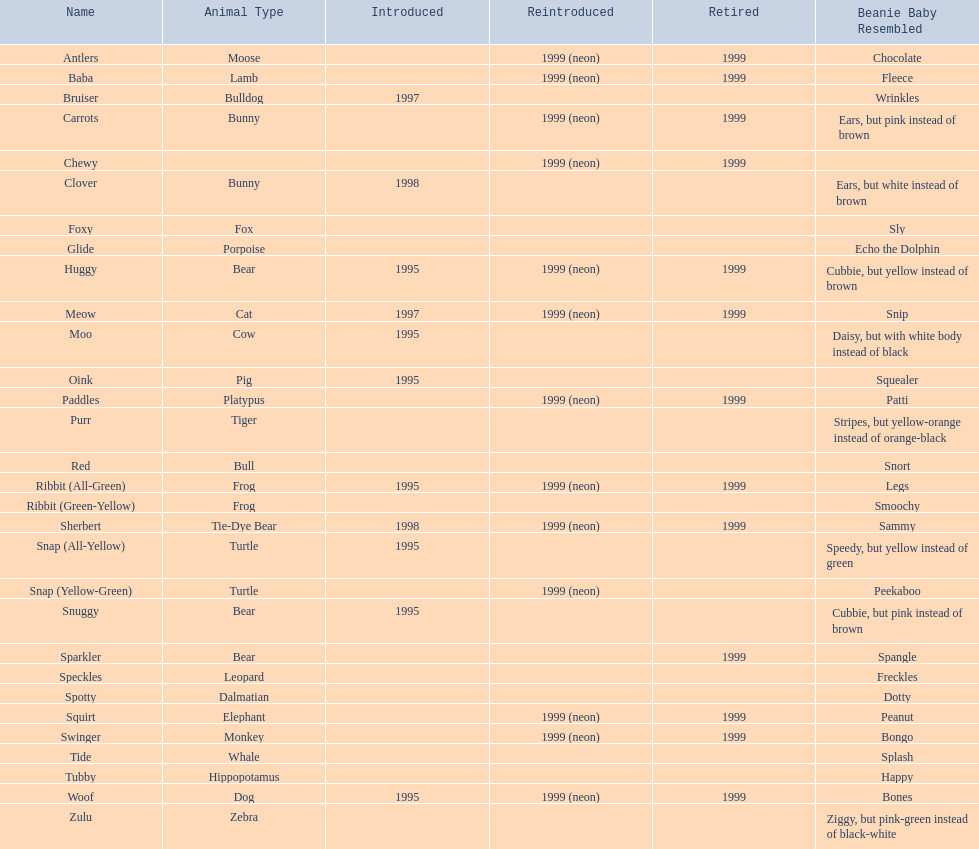What animals are pillow pals? Moose, Lamb, Bulldog, Bunny, Bunny, Fox, Porpoise, Bear, Cat, Cow, Pig, Platypus, Tiger, Bull, Frog, Frog, Tie-Dye Bear, Turtle, Turtle, Bear, Bear, Leopard, Dalmatian, Elephant, Monkey, Whale, Hippopotamus, Dog, Zebra. What is the name of the dalmatian? Spotty. 